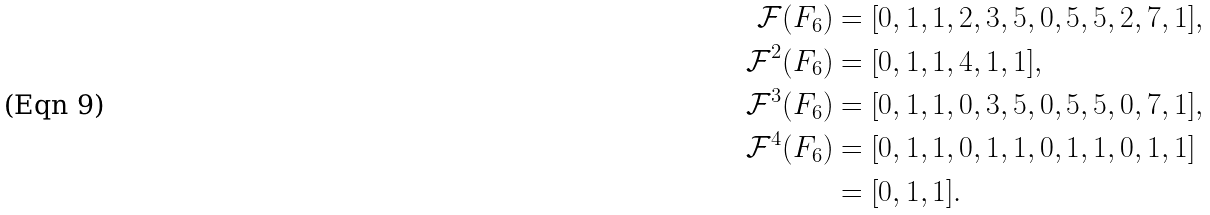<formula> <loc_0><loc_0><loc_500><loc_500>{ \mathcal { F } } ( F _ { 6 } ) & = [ 0 , 1 , 1 , 2 , 3 , 5 , 0 , 5 , 5 , 2 , 7 , 1 ] , \\ { \mathcal { F } } ^ { 2 } ( F _ { 6 } ) & = [ 0 , 1 , 1 , 4 , 1 , 1 ] , \\ { \mathcal { F } } ^ { 3 } ( F _ { 6 } ) & = [ 0 , 1 , 1 , 0 , 3 , 5 , 0 , 5 , 5 , 0 , 7 , 1 ] , \\ { \mathcal { F } } ^ { 4 } ( F _ { 6 } ) & = [ 0 , 1 , 1 , 0 , 1 , 1 , 0 , 1 , 1 , 0 , 1 , 1 ] \\ & = [ 0 , 1 , 1 ] .</formula> 